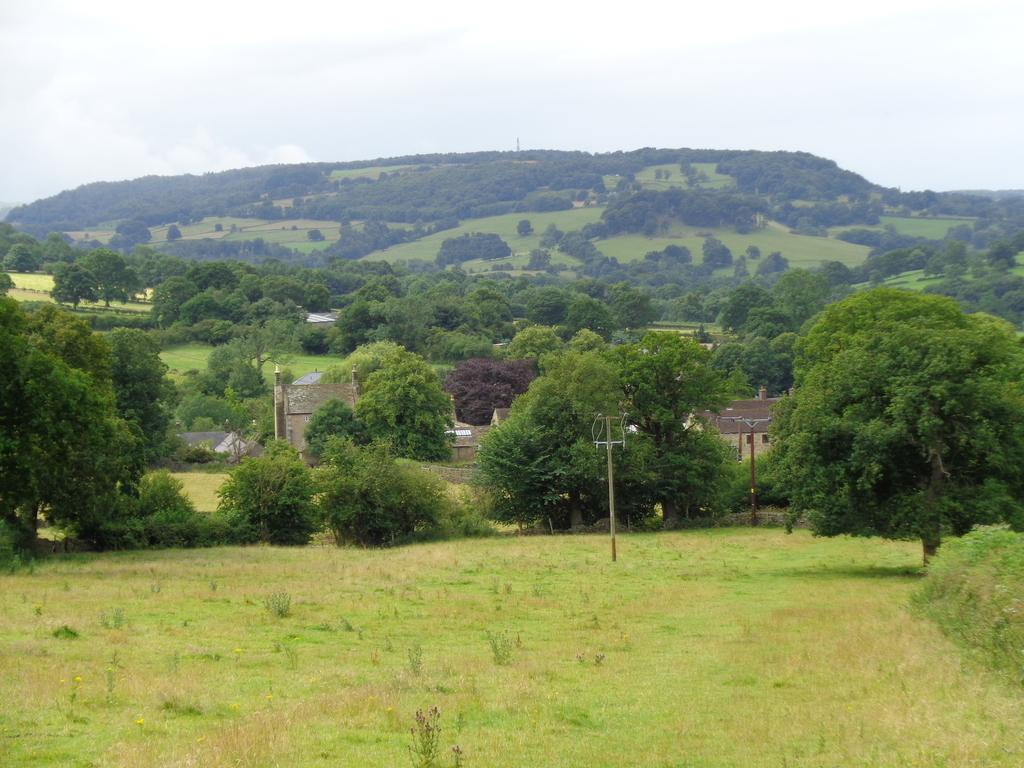What is located in the center of the image? There are trees and poles in the center of the image. What type of structures can be seen in the image? There are sheds in the image. What is visible in the background of the image? There is a hill and the sky visible in the background of the image. What type of lumber is being used to construct the door in the image? There is no door present in the image; it features trees, poles, sheds, a hill, and the sky. How many spades are visible in the image? There are no spades visible in the image. 